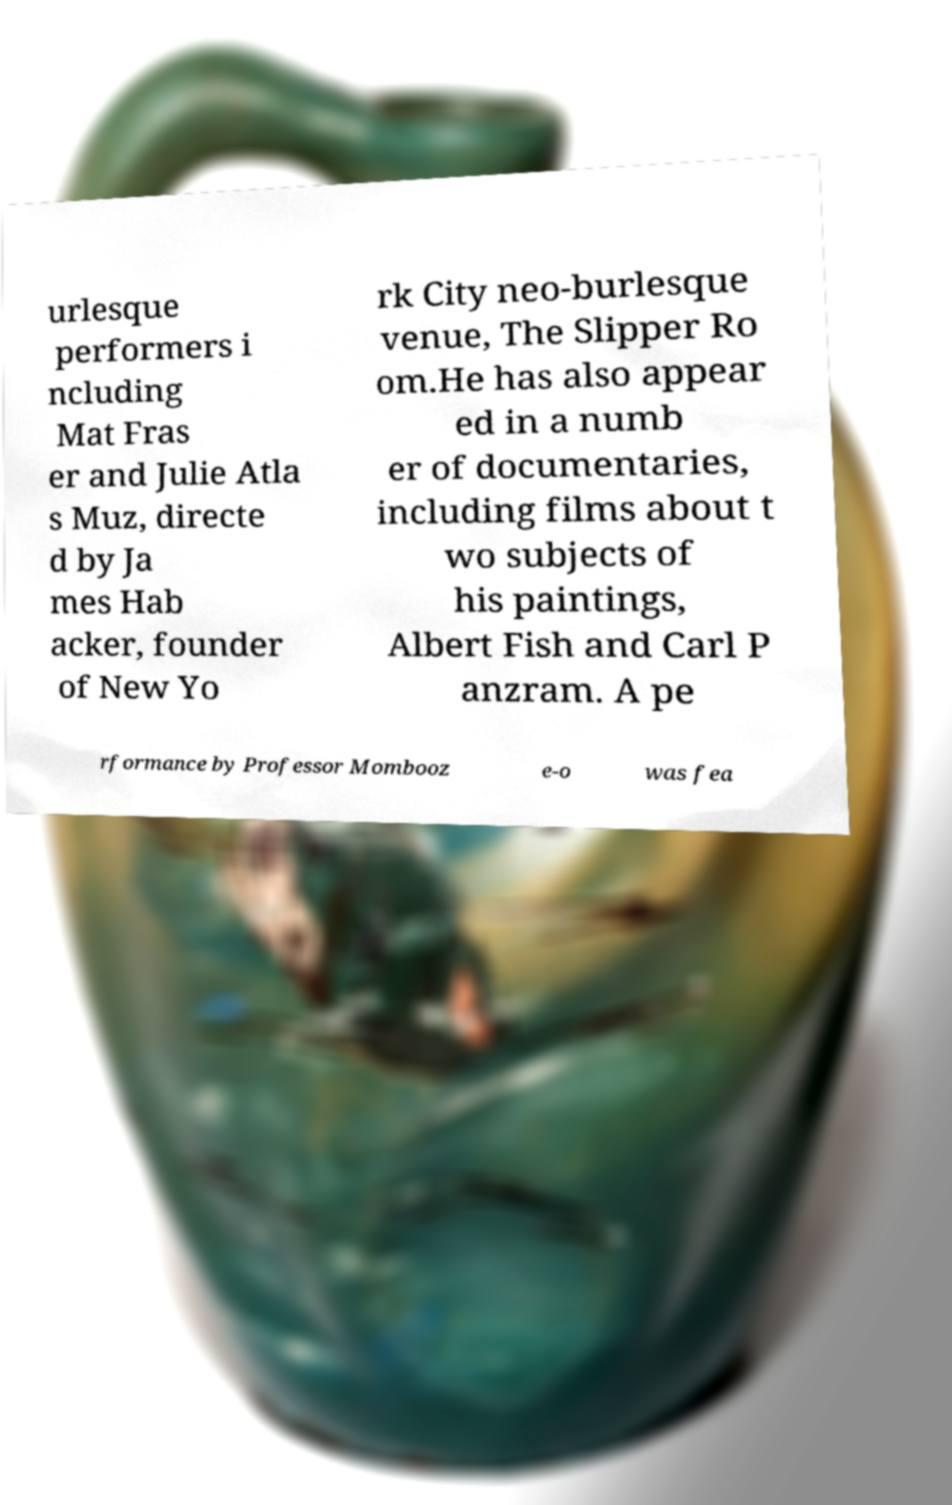There's text embedded in this image that I need extracted. Can you transcribe it verbatim? urlesque performers i ncluding Mat Fras er and Julie Atla s Muz, directe d by Ja mes Hab acker, founder of New Yo rk City neo-burlesque venue, The Slipper Ro om.He has also appear ed in a numb er of documentaries, including films about t wo subjects of his paintings, Albert Fish and Carl P anzram. A pe rformance by Professor Mombooz e-o was fea 